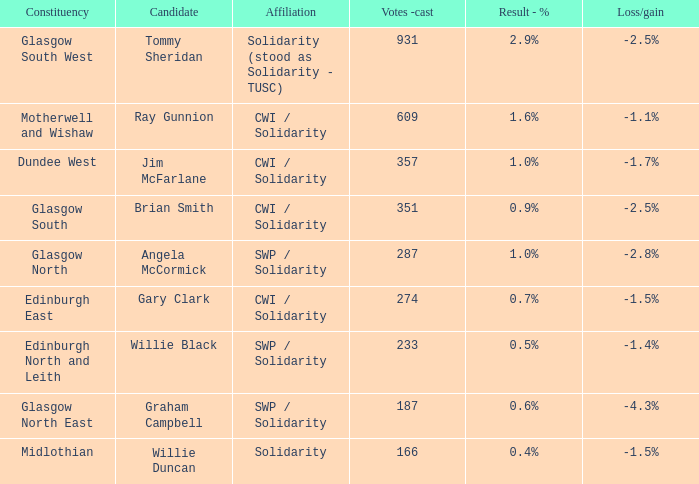How many votes were cast when the constituency was midlothian? 166.0. 